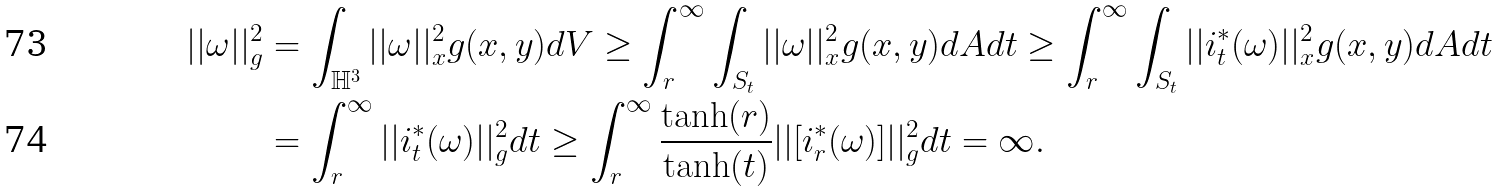Convert formula to latex. <formula><loc_0><loc_0><loc_500><loc_500>| | \omega | | ^ { 2 } _ { g } & = \int _ { \mathbb { H } ^ { 3 } } | | \omega | | ^ { 2 } _ { x } g ( x , y ) d V \geq \int ^ { \infty } _ { r } \int _ { S _ { t } } | | \omega | | ^ { 2 } _ { x } g ( x , y ) d A d t \geq \int ^ { \infty } _ { r } \int _ { S _ { t } } | | i _ { t } ^ { \ast } ( \omega ) | | ^ { 2 } _ { x } g ( x , y ) d A d t \\ & = \int ^ { \infty } _ { r } | | i _ { t } ^ { \ast } ( \omega ) | | ^ { 2 } _ { g } d t \geq \int ^ { \infty } _ { r } \frac { \tanh ( r ) } { \tanh ( t ) } | | [ i _ { r } ^ { \ast } ( \omega ) ] | | ^ { 2 } _ { g } d t = \infty .</formula> 